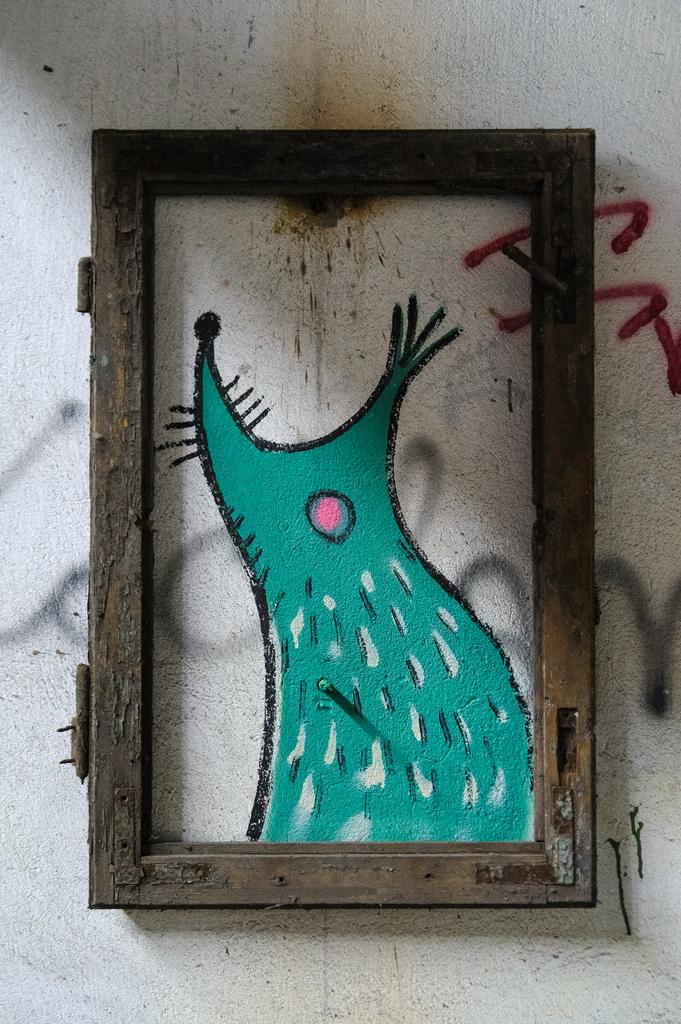What is the main object in the image? There is a frame in the image. What is inside the frame? There is a painting inside the frame. Where is the frame and painting located? The painting and frame are on a wall. What type of wilderness can be seen in the painting? There is no wilderness visible in the painting, as the facts only mention that there is a painting inside the frame. 